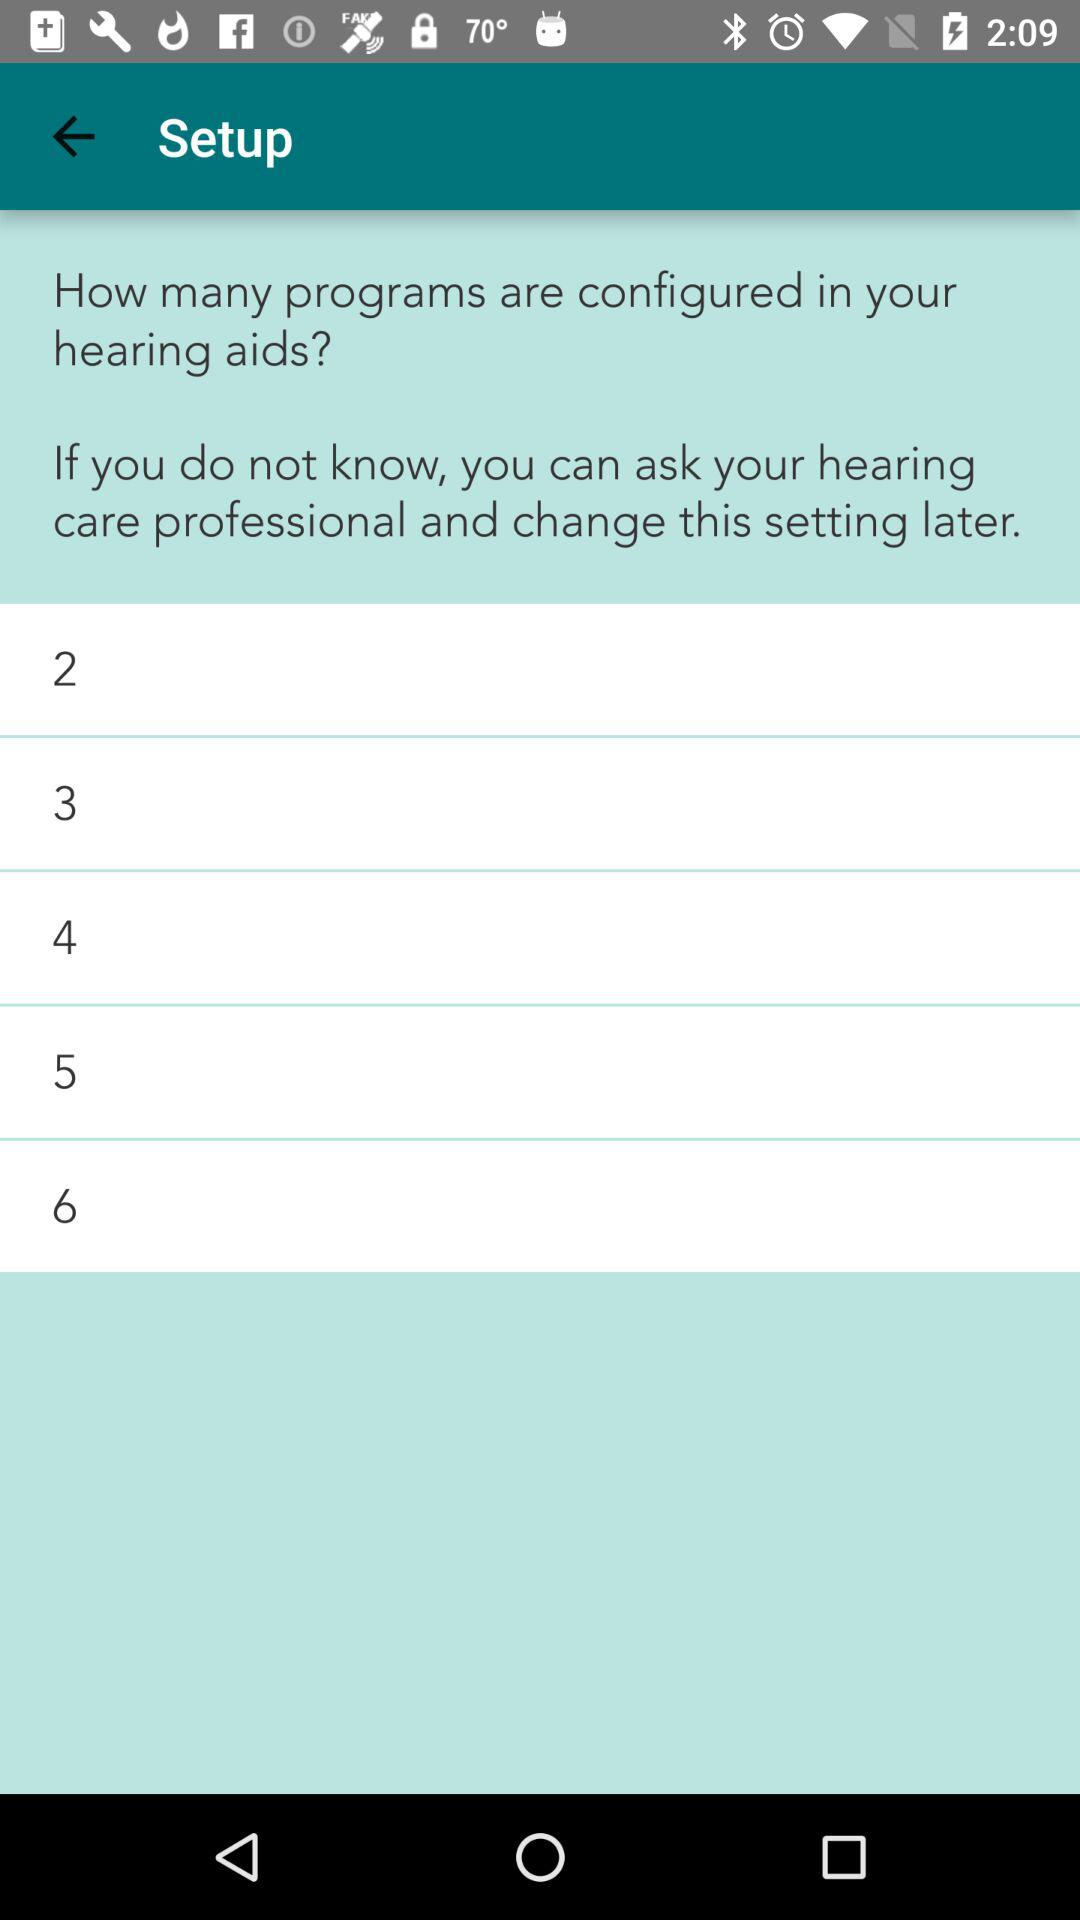How many programs are configured?
Answer the question using a single word or phrase. 6 